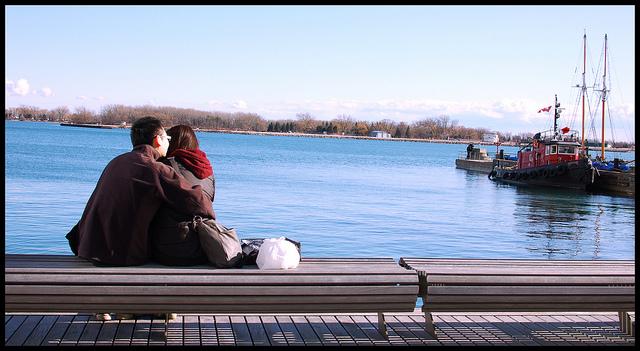How many people are in the photo?
Quick response, please. 2. Does the bench have a backrest?
Write a very short answer. No. What indicates that it is not summer?
Answer briefly. Jackets. 